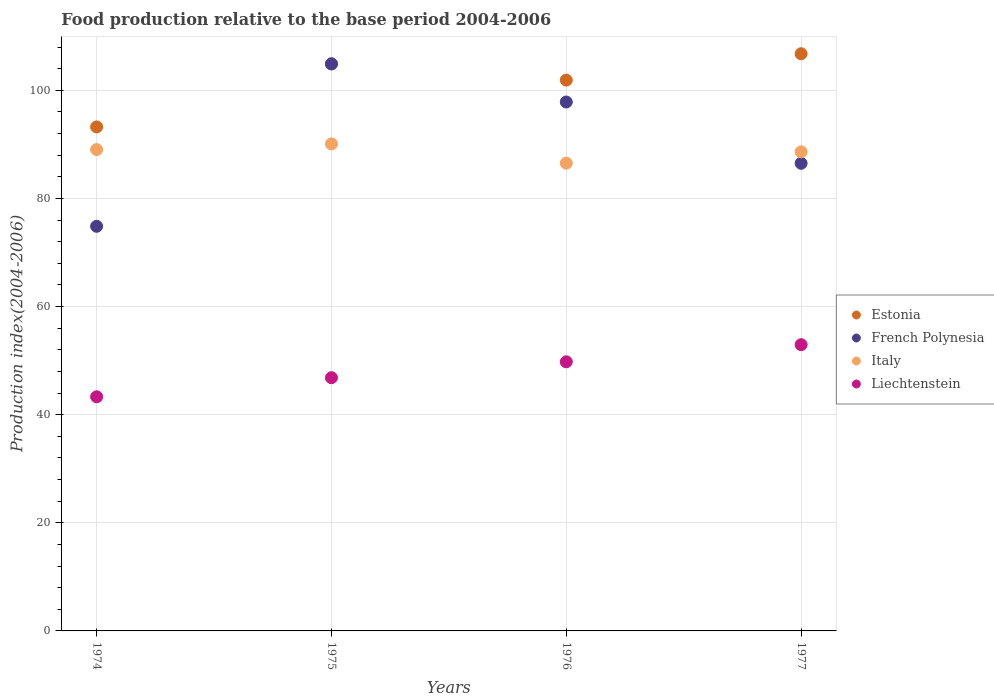What is the food production index in Estonia in 1975?
Your answer should be very brief. 104.89. Across all years, what is the maximum food production index in Liechtenstein?
Offer a terse response. 52.95. Across all years, what is the minimum food production index in Estonia?
Your response must be concise. 93.23. In which year was the food production index in Italy maximum?
Provide a succinct answer. 1975. In which year was the food production index in Estonia minimum?
Your answer should be very brief. 1974. What is the total food production index in Liechtenstein in the graph?
Provide a succinct answer. 192.88. What is the difference between the food production index in Italy in 1974 and that in 1976?
Keep it short and to the point. 2.51. What is the difference between the food production index in Liechtenstein in 1975 and the food production index in Estonia in 1976?
Ensure brevity in your answer.  -55.05. What is the average food production index in Estonia per year?
Provide a succinct answer. 101.69. In the year 1975, what is the difference between the food production index in Liechtenstein and food production index in Estonia?
Keep it short and to the point. -58.05. What is the ratio of the food production index in Italy in 1976 to that in 1977?
Your answer should be very brief. 0.98. Is the difference between the food production index in Liechtenstein in 1975 and 1977 greater than the difference between the food production index in Estonia in 1975 and 1977?
Make the answer very short. No. What is the difference between the highest and the second highest food production index in Estonia?
Your answer should be compact. 1.88. What is the difference between the highest and the lowest food production index in Liechtenstein?
Offer a very short reply. 9.64. In how many years, is the food production index in French Polynesia greater than the average food production index in French Polynesia taken over all years?
Your response must be concise. 2. Is the food production index in Italy strictly greater than the food production index in Liechtenstein over the years?
Your response must be concise. Yes. Is the food production index in Estonia strictly less than the food production index in French Polynesia over the years?
Give a very brief answer. No. How many dotlines are there?
Keep it short and to the point. 4. How many years are there in the graph?
Give a very brief answer. 4. What is the difference between two consecutive major ticks on the Y-axis?
Provide a succinct answer. 20. Does the graph contain grids?
Your response must be concise. Yes. How many legend labels are there?
Make the answer very short. 4. How are the legend labels stacked?
Your answer should be compact. Vertical. What is the title of the graph?
Give a very brief answer. Food production relative to the base period 2004-2006. Does "Other small states" appear as one of the legend labels in the graph?
Offer a terse response. No. What is the label or title of the Y-axis?
Your answer should be very brief. Production index(2004-2006). What is the Production index(2004-2006) in Estonia in 1974?
Your answer should be very brief. 93.23. What is the Production index(2004-2006) of French Polynesia in 1974?
Keep it short and to the point. 74.85. What is the Production index(2004-2006) of Italy in 1974?
Ensure brevity in your answer.  89.04. What is the Production index(2004-2006) of Liechtenstein in 1974?
Make the answer very short. 43.31. What is the Production index(2004-2006) of Estonia in 1975?
Offer a very short reply. 104.89. What is the Production index(2004-2006) in French Polynesia in 1975?
Your answer should be compact. 104.9. What is the Production index(2004-2006) of Italy in 1975?
Give a very brief answer. 90.09. What is the Production index(2004-2006) in Liechtenstein in 1975?
Provide a short and direct response. 46.84. What is the Production index(2004-2006) in Estonia in 1976?
Keep it short and to the point. 101.89. What is the Production index(2004-2006) in French Polynesia in 1976?
Ensure brevity in your answer.  97.84. What is the Production index(2004-2006) in Italy in 1976?
Make the answer very short. 86.53. What is the Production index(2004-2006) of Liechtenstein in 1976?
Provide a succinct answer. 49.78. What is the Production index(2004-2006) of Estonia in 1977?
Ensure brevity in your answer.  106.77. What is the Production index(2004-2006) in French Polynesia in 1977?
Ensure brevity in your answer.  86.5. What is the Production index(2004-2006) of Italy in 1977?
Make the answer very short. 88.62. What is the Production index(2004-2006) of Liechtenstein in 1977?
Offer a very short reply. 52.95. Across all years, what is the maximum Production index(2004-2006) in Estonia?
Your answer should be very brief. 106.77. Across all years, what is the maximum Production index(2004-2006) of French Polynesia?
Your answer should be compact. 104.9. Across all years, what is the maximum Production index(2004-2006) in Italy?
Offer a terse response. 90.09. Across all years, what is the maximum Production index(2004-2006) in Liechtenstein?
Offer a very short reply. 52.95. Across all years, what is the minimum Production index(2004-2006) of Estonia?
Offer a very short reply. 93.23. Across all years, what is the minimum Production index(2004-2006) of French Polynesia?
Give a very brief answer. 74.85. Across all years, what is the minimum Production index(2004-2006) of Italy?
Give a very brief answer. 86.53. Across all years, what is the minimum Production index(2004-2006) in Liechtenstein?
Offer a very short reply. 43.31. What is the total Production index(2004-2006) of Estonia in the graph?
Give a very brief answer. 406.78. What is the total Production index(2004-2006) of French Polynesia in the graph?
Give a very brief answer. 364.09. What is the total Production index(2004-2006) of Italy in the graph?
Your response must be concise. 354.28. What is the total Production index(2004-2006) of Liechtenstein in the graph?
Provide a succinct answer. 192.88. What is the difference between the Production index(2004-2006) of Estonia in 1974 and that in 1975?
Your answer should be compact. -11.66. What is the difference between the Production index(2004-2006) of French Polynesia in 1974 and that in 1975?
Give a very brief answer. -30.05. What is the difference between the Production index(2004-2006) in Italy in 1974 and that in 1975?
Your response must be concise. -1.05. What is the difference between the Production index(2004-2006) in Liechtenstein in 1974 and that in 1975?
Ensure brevity in your answer.  -3.53. What is the difference between the Production index(2004-2006) of Estonia in 1974 and that in 1976?
Your answer should be very brief. -8.66. What is the difference between the Production index(2004-2006) in French Polynesia in 1974 and that in 1976?
Your response must be concise. -22.99. What is the difference between the Production index(2004-2006) of Italy in 1974 and that in 1976?
Offer a very short reply. 2.51. What is the difference between the Production index(2004-2006) in Liechtenstein in 1974 and that in 1976?
Your answer should be very brief. -6.47. What is the difference between the Production index(2004-2006) in Estonia in 1974 and that in 1977?
Offer a terse response. -13.54. What is the difference between the Production index(2004-2006) of French Polynesia in 1974 and that in 1977?
Make the answer very short. -11.65. What is the difference between the Production index(2004-2006) in Italy in 1974 and that in 1977?
Provide a succinct answer. 0.42. What is the difference between the Production index(2004-2006) in Liechtenstein in 1974 and that in 1977?
Your response must be concise. -9.64. What is the difference between the Production index(2004-2006) of Estonia in 1975 and that in 1976?
Your answer should be compact. 3. What is the difference between the Production index(2004-2006) in French Polynesia in 1975 and that in 1976?
Offer a very short reply. 7.06. What is the difference between the Production index(2004-2006) of Italy in 1975 and that in 1976?
Offer a terse response. 3.56. What is the difference between the Production index(2004-2006) in Liechtenstein in 1975 and that in 1976?
Keep it short and to the point. -2.94. What is the difference between the Production index(2004-2006) of Estonia in 1975 and that in 1977?
Your answer should be very brief. -1.88. What is the difference between the Production index(2004-2006) of French Polynesia in 1975 and that in 1977?
Provide a short and direct response. 18.4. What is the difference between the Production index(2004-2006) in Italy in 1975 and that in 1977?
Provide a succinct answer. 1.47. What is the difference between the Production index(2004-2006) of Liechtenstein in 1975 and that in 1977?
Offer a very short reply. -6.11. What is the difference between the Production index(2004-2006) in Estonia in 1976 and that in 1977?
Your answer should be compact. -4.88. What is the difference between the Production index(2004-2006) of French Polynesia in 1976 and that in 1977?
Provide a succinct answer. 11.34. What is the difference between the Production index(2004-2006) in Italy in 1976 and that in 1977?
Ensure brevity in your answer.  -2.09. What is the difference between the Production index(2004-2006) of Liechtenstein in 1976 and that in 1977?
Give a very brief answer. -3.17. What is the difference between the Production index(2004-2006) of Estonia in 1974 and the Production index(2004-2006) of French Polynesia in 1975?
Your answer should be compact. -11.67. What is the difference between the Production index(2004-2006) of Estonia in 1974 and the Production index(2004-2006) of Italy in 1975?
Provide a short and direct response. 3.14. What is the difference between the Production index(2004-2006) in Estonia in 1974 and the Production index(2004-2006) in Liechtenstein in 1975?
Make the answer very short. 46.39. What is the difference between the Production index(2004-2006) in French Polynesia in 1974 and the Production index(2004-2006) in Italy in 1975?
Make the answer very short. -15.24. What is the difference between the Production index(2004-2006) in French Polynesia in 1974 and the Production index(2004-2006) in Liechtenstein in 1975?
Provide a succinct answer. 28.01. What is the difference between the Production index(2004-2006) in Italy in 1974 and the Production index(2004-2006) in Liechtenstein in 1975?
Make the answer very short. 42.2. What is the difference between the Production index(2004-2006) of Estonia in 1974 and the Production index(2004-2006) of French Polynesia in 1976?
Provide a succinct answer. -4.61. What is the difference between the Production index(2004-2006) of Estonia in 1974 and the Production index(2004-2006) of Liechtenstein in 1976?
Provide a succinct answer. 43.45. What is the difference between the Production index(2004-2006) in French Polynesia in 1974 and the Production index(2004-2006) in Italy in 1976?
Ensure brevity in your answer.  -11.68. What is the difference between the Production index(2004-2006) in French Polynesia in 1974 and the Production index(2004-2006) in Liechtenstein in 1976?
Provide a succinct answer. 25.07. What is the difference between the Production index(2004-2006) of Italy in 1974 and the Production index(2004-2006) of Liechtenstein in 1976?
Offer a very short reply. 39.26. What is the difference between the Production index(2004-2006) of Estonia in 1974 and the Production index(2004-2006) of French Polynesia in 1977?
Your answer should be compact. 6.73. What is the difference between the Production index(2004-2006) of Estonia in 1974 and the Production index(2004-2006) of Italy in 1977?
Offer a very short reply. 4.61. What is the difference between the Production index(2004-2006) of Estonia in 1974 and the Production index(2004-2006) of Liechtenstein in 1977?
Keep it short and to the point. 40.28. What is the difference between the Production index(2004-2006) of French Polynesia in 1974 and the Production index(2004-2006) of Italy in 1977?
Your answer should be very brief. -13.77. What is the difference between the Production index(2004-2006) in French Polynesia in 1974 and the Production index(2004-2006) in Liechtenstein in 1977?
Keep it short and to the point. 21.9. What is the difference between the Production index(2004-2006) of Italy in 1974 and the Production index(2004-2006) of Liechtenstein in 1977?
Make the answer very short. 36.09. What is the difference between the Production index(2004-2006) of Estonia in 1975 and the Production index(2004-2006) of French Polynesia in 1976?
Give a very brief answer. 7.05. What is the difference between the Production index(2004-2006) in Estonia in 1975 and the Production index(2004-2006) in Italy in 1976?
Provide a short and direct response. 18.36. What is the difference between the Production index(2004-2006) in Estonia in 1975 and the Production index(2004-2006) in Liechtenstein in 1976?
Give a very brief answer. 55.11. What is the difference between the Production index(2004-2006) in French Polynesia in 1975 and the Production index(2004-2006) in Italy in 1976?
Make the answer very short. 18.37. What is the difference between the Production index(2004-2006) in French Polynesia in 1975 and the Production index(2004-2006) in Liechtenstein in 1976?
Give a very brief answer. 55.12. What is the difference between the Production index(2004-2006) in Italy in 1975 and the Production index(2004-2006) in Liechtenstein in 1976?
Keep it short and to the point. 40.31. What is the difference between the Production index(2004-2006) of Estonia in 1975 and the Production index(2004-2006) of French Polynesia in 1977?
Keep it short and to the point. 18.39. What is the difference between the Production index(2004-2006) of Estonia in 1975 and the Production index(2004-2006) of Italy in 1977?
Keep it short and to the point. 16.27. What is the difference between the Production index(2004-2006) in Estonia in 1975 and the Production index(2004-2006) in Liechtenstein in 1977?
Ensure brevity in your answer.  51.94. What is the difference between the Production index(2004-2006) of French Polynesia in 1975 and the Production index(2004-2006) of Italy in 1977?
Offer a terse response. 16.28. What is the difference between the Production index(2004-2006) of French Polynesia in 1975 and the Production index(2004-2006) of Liechtenstein in 1977?
Your answer should be compact. 51.95. What is the difference between the Production index(2004-2006) in Italy in 1975 and the Production index(2004-2006) in Liechtenstein in 1977?
Give a very brief answer. 37.14. What is the difference between the Production index(2004-2006) of Estonia in 1976 and the Production index(2004-2006) of French Polynesia in 1977?
Ensure brevity in your answer.  15.39. What is the difference between the Production index(2004-2006) in Estonia in 1976 and the Production index(2004-2006) in Italy in 1977?
Give a very brief answer. 13.27. What is the difference between the Production index(2004-2006) of Estonia in 1976 and the Production index(2004-2006) of Liechtenstein in 1977?
Give a very brief answer. 48.94. What is the difference between the Production index(2004-2006) in French Polynesia in 1976 and the Production index(2004-2006) in Italy in 1977?
Your answer should be compact. 9.22. What is the difference between the Production index(2004-2006) in French Polynesia in 1976 and the Production index(2004-2006) in Liechtenstein in 1977?
Keep it short and to the point. 44.89. What is the difference between the Production index(2004-2006) of Italy in 1976 and the Production index(2004-2006) of Liechtenstein in 1977?
Keep it short and to the point. 33.58. What is the average Production index(2004-2006) in Estonia per year?
Keep it short and to the point. 101.69. What is the average Production index(2004-2006) of French Polynesia per year?
Give a very brief answer. 91.02. What is the average Production index(2004-2006) of Italy per year?
Your answer should be compact. 88.57. What is the average Production index(2004-2006) of Liechtenstein per year?
Give a very brief answer. 48.22. In the year 1974, what is the difference between the Production index(2004-2006) in Estonia and Production index(2004-2006) in French Polynesia?
Keep it short and to the point. 18.38. In the year 1974, what is the difference between the Production index(2004-2006) of Estonia and Production index(2004-2006) of Italy?
Make the answer very short. 4.19. In the year 1974, what is the difference between the Production index(2004-2006) of Estonia and Production index(2004-2006) of Liechtenstein?
Offer a very short reply. 49.92. In the year 1974, what is the difference between the Production index(2004-2006) of French Polynesia and Production index(2004-2006) of Italy?
Keep it short and to the point. -14.19. In the year 1974, what is the difference between the Production index(2004-2006) in French Polynesia and Production index(2004-2006) in Liechtenstein?
Offer a very short reply. 31.54. In the year 1974, what is the difference between the Production index(2004-2006) in Italy and Production index(2004-2006) in Liechtenstein?
Give a very brief answer. 45.73. In the year 1975, what is the difference between the Production index(2004-2006) in Estonia and Production index(2004-2006) in French Polynesia?
Provide a short and direct response. -0.01. In the year 1975, what is the difference between the Production index(2004-2006) in Estonia and Production index(2004-2006) in Liechtenstein?
Your answer should be compact. 58.05. In the year 1975, what is the difference between the Production index(2004-2006) in French Polynesia and Production index(2004-2006) in Italy?
Make the answer very short. 14.81. In the year 1975, what is the difference between the Production index(2004-2006) in French Polynesia and Production index(2004-2006) in Liechtenstein?
Make the answer very short. 58.06. In the year 1975, what is the difference between the Production index(2004-2006) in Italy and Production index(2004-2006) in Liechtenstein?
Offer a terse response. 43.25. In the year 1976, what is the difference between the Production index(2004-2006) in Estonia and Production index(2004-2006) in French Polynesia?
Your answer should be compact. 4.05. In the year 1976, what is the difference between the Production index(2004-2006) of Estonia and Production index(2004-2006) of Italy?
Give a very brief answer. 15.36. In the year 1976, what is the difference between the Production index(2004-2006) in Estonia and Production index(2004-2006) in Liechtenstein?
Give a very brief answer. 52.11. In the year 1976, what is the difference between the Production index(2004-2006) in French Polynesia and Production index(2004-2006) in Italy?
Provide a succinct answer. 11.31. In the year 1976, what is the difference between the Production index(2004-2006) in French Polynesia and Production index(2004-2006) in Liechtenstein?
Offer a terse response. 48.06. In the year 1976, what is the difference between the Production index(2004-2006) of Italy and Production index(2004-2006) of Liechtenstein?
Make the answer very short. 36.75. In the year 1977, what is the difference between the Production index(2004-2006) of Estonia and Production index(2004-2006) of French Polynesia?
Your answer should be very brief. 20.27. In the year 1977, what is the difference between the Production index(2004-2006) in Estonia and Production index(2004-2006) in Italy?
Your answer should be compact. 18.15. In the year 1977, what is the difference between the Production index(2004-2006) of Estonia and Production index(2004-2006) of Liechtenstein?
Offer a terse response. 53.82. In the year 1977, what is the difference between the Production index(2004-2006) of French Polynesia and Production index(2004-2006) of Italy?
Your answer should be compact. -2.12. In the year 1977, what is the difference between the Production index(2004-2006) of French Polynesia and Production index(2004-2006) of Liechtenstein?
Keep it short and to the point. 33.55. In the year 1977, what is the difference between the Production index(2004-2006) in Italy and Production index(2004-2006) in Liechtenstein?
Your answer should be compact. 35.67. What is the ratio of the Production index(2004-2006) of Estonia in 1974 to that in 1975?
Your response must be concise. 0.89. What is the ratio of the Production index(2004-2006) of French Polynesia in 1974 to that in 1975?
Offer a very short reply. 0.71. What is the ratio of the Production index(2004-2006) of Italy in 1974 to that in 1975?
Offer a very short reply. 0.99. What is the ratio of the Production index(2004-2006) in Liechtenstein in 1974 to that in 1975?
Your answer should be very brief. 0.92. What is the ratio of the Production index(2004-2006) of Estonia in 1974 to that in 1976?
Provide a succinct answer. 0.92. What is the ratio of the Production index(2004-2006) of French Polynesia in 1974 to that in 1976?
Make the answer very short. 0.77. What is the ratio of the Production index(2004-2006) of Liechtenstein in 1974 to that in 1976?
Provide a succinct answer. 0.87. What is the ratio of the Production index(2004-2006) of Estonia in 1974 to that in 1977?
Offer a terse response. 0.87. What is the ratio of the Production index(2004-2006) of French Polynesia in 1974 to that in 1977?
Your answer should be very brief. 0.87. What is the ratio of the Production index(2004-2006) of Liechtenstein in 1974 to that in 1977?
Offer a very short reply. 0.82. What is the ratio of the Production index(2004-2006) in Estonia in 1975 to that in 1976?
Offer a very short reply. 1.03. What is the ratio of the Production index(2004-2006) of French Polynesia in 1975 to that in 1976?
Provide a short and direct response. 1.07. What is the ratio of the Production index(2004-2006) of Italy in 1975 to that in 1976?
Provide a succinct answer. 1.04. What is the ratio of the Production index(2004-2006) of Liechtenstein in 1975 to that in 1976?
Your answer should be very brief. 0.94. What is the ratio of the Production index(2004-2006) in Estonia in 1975 to that in 1977?
Make the answer very short. 0.98. What is the ratio of the Production index(2004-2006) of French Polynesia in 1975 to that in 1977?
Give a very brief answer. 1.21. What is the ratio of the Production index(2004-2006) in Italy in 1975 to that in 1977?
Make the answer very short. 1.02. What is the ratio of the Production index(2004-2006) in Liechtenstein in 1975 to that in 1977?
Ensure brevity in your answer.  0.88. What is the ratio of the Production index(2004-2006) in Estonia in 1976 to that in 1977?
Your answer should be compact. 0.95. What is the ratio of the Production index(2004-2006) in French Polynesia in 1976 to that in 1977?
Your answer should be compact. 1.13. What is the ratio of the Production index(2004-2006) in Italy in 1976 to that in 1977?
Ensure brevity in your answer.  0.98. What is the ratio of the Production index(2004-2006) of Liechtenstein in 1976 to that in 1977?
Your answer should be compact. 0.94. What is the difference between the highest and the second highest Production index(2004-2006) in Estonia?
Your answer should be very brief. 1.88. What is the difference between the highest and the second highest Production index(2004-2006) of French Polynesia?
Give a very brief answer. 7.06. What is the difference between the highest and the second highest Production index(2004-2006) of Liechtenstein?
Your answer should be compact. 3.17. What is the difference between the highest and the lowest Production index(2004-2006) of Estonia?
Ensure brevity in your answer.  13.54. What is the difference between the highest and the lowest Production index(2004-2006) of French Polynesia?
Make the answer very short. 30.05. What is the difference between the highest and the lowest Production index(2004-2006) of Italy?
Ensure brevity in your answer.  3.56. What is the difference between the highest and the lowest Production index(2004-2006) of Liechtenstein?
Ensure brevity in your answer.  9.64. 